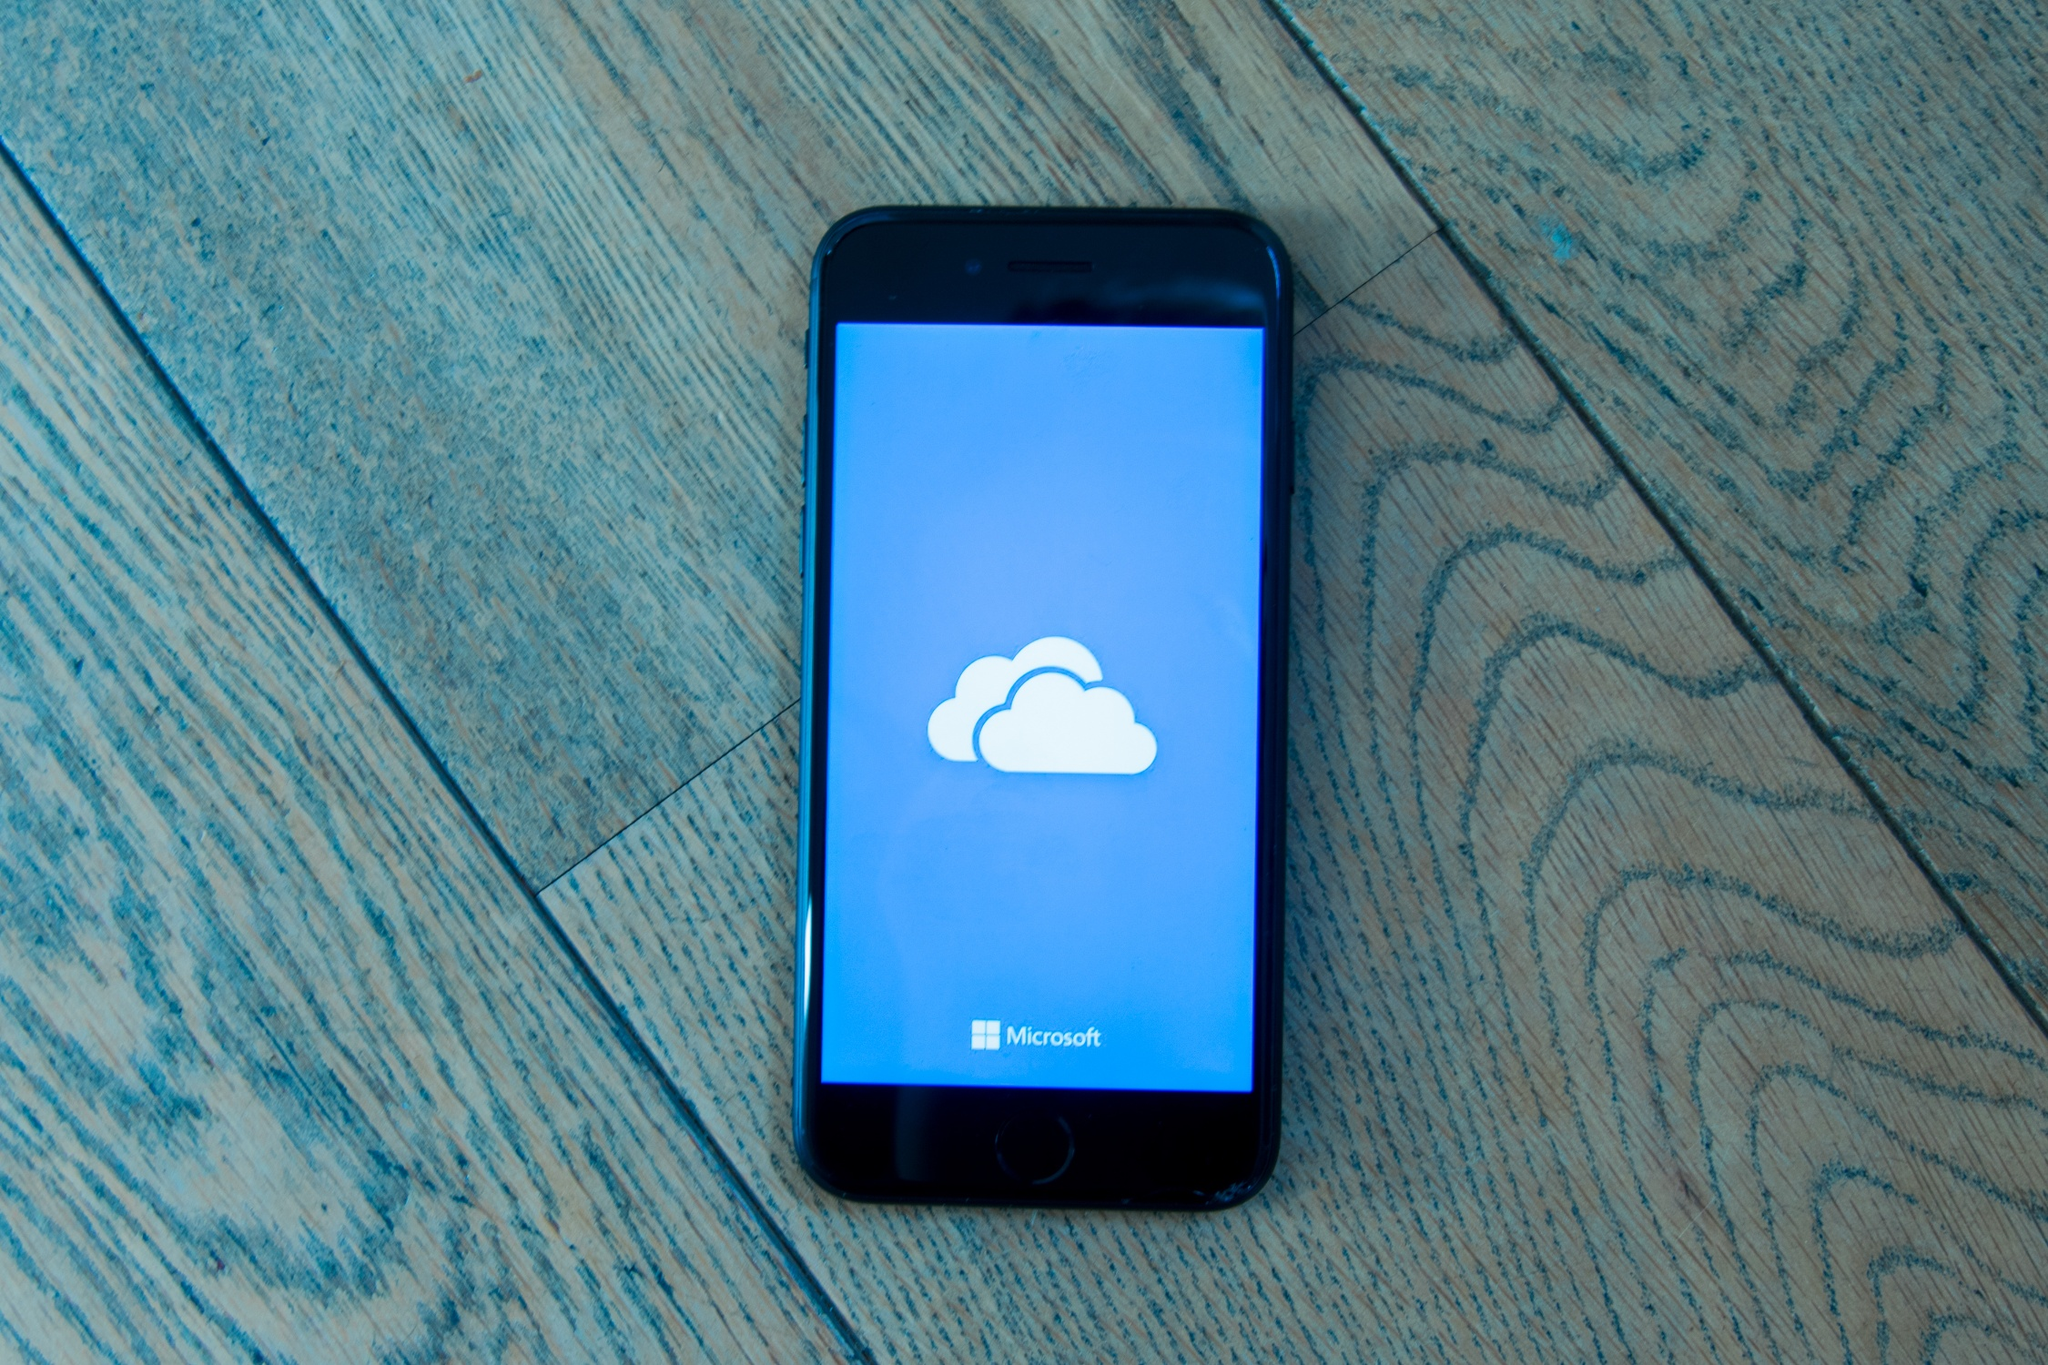Describe the mood and atmosphere conveyed by the image. The mood of the image appears quite casual and spontaneous, suggested by the iPhone's diagonal placement on the patterned wooden floor. The simplicity and focus of the scene, with the lone iPhone displaying a cloud icon and the word 'Microsoft,' invoke a sense of modern connectivity and technological efficiency. The overall atmosphere is minimalistic yet thoughtful, subtly emphasizing the seamless integration of technology into everyday life. How does the positioning of the iPhone and the design of the floor contribute to the overall feel of the image? The diagonal positioning of the iPhone on the patterned wooden floor contributes extensively to the image’s dynamic feel. The floor’s diagonal pattern creates a visual pathway that guides the viewer’s eye directly to the phone, enhancing the sense of depth and perspective. This alignment not only establishes a casual and unpremeditated ambiance but also underlines the importance of the phone and the information displayed on its screen. This thoughtful positioning underscores the primary focus on the interplay between digital technology and everyday settings. Imagine if the image was part of a marketing campaign. What message could it be trying to convey, and how effectively does it do this? If this image were part of a marketing campaign, it could be conveying the message of seamless and accessible cloud storage solutions provided by Microsoft. The clear, uncluttered composition focuses on the iPhone, a ubiquitous symbol of modern communication, with Microsoft’s cloud service prominently displayed. This effectively communicates the integration and ease of use of Microsoft’s cloud solutions in daily life. The casual yet deliberate placement on the simple wooden floor suggests reliability and accessibility, further reinforcing the idea that Microsoft’s technology is an integral, user-friendly part of our everyday environment. The campaign effectively highlights the practicality and omnipresence of Microsoft's cloud services, making the viewer contemplate the essential role of reliable data storage. 